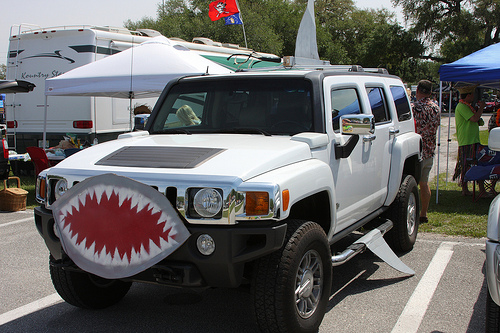<image>
Is the man behind the tree? No. The man is not behind the tree. From this viewpoint, the man appears to be positioned elsewhere in the scene. Is there a windshield above the headlight? No. The windshield is not positioned above the headlight. The vertical arrangement shows a different relationship. 